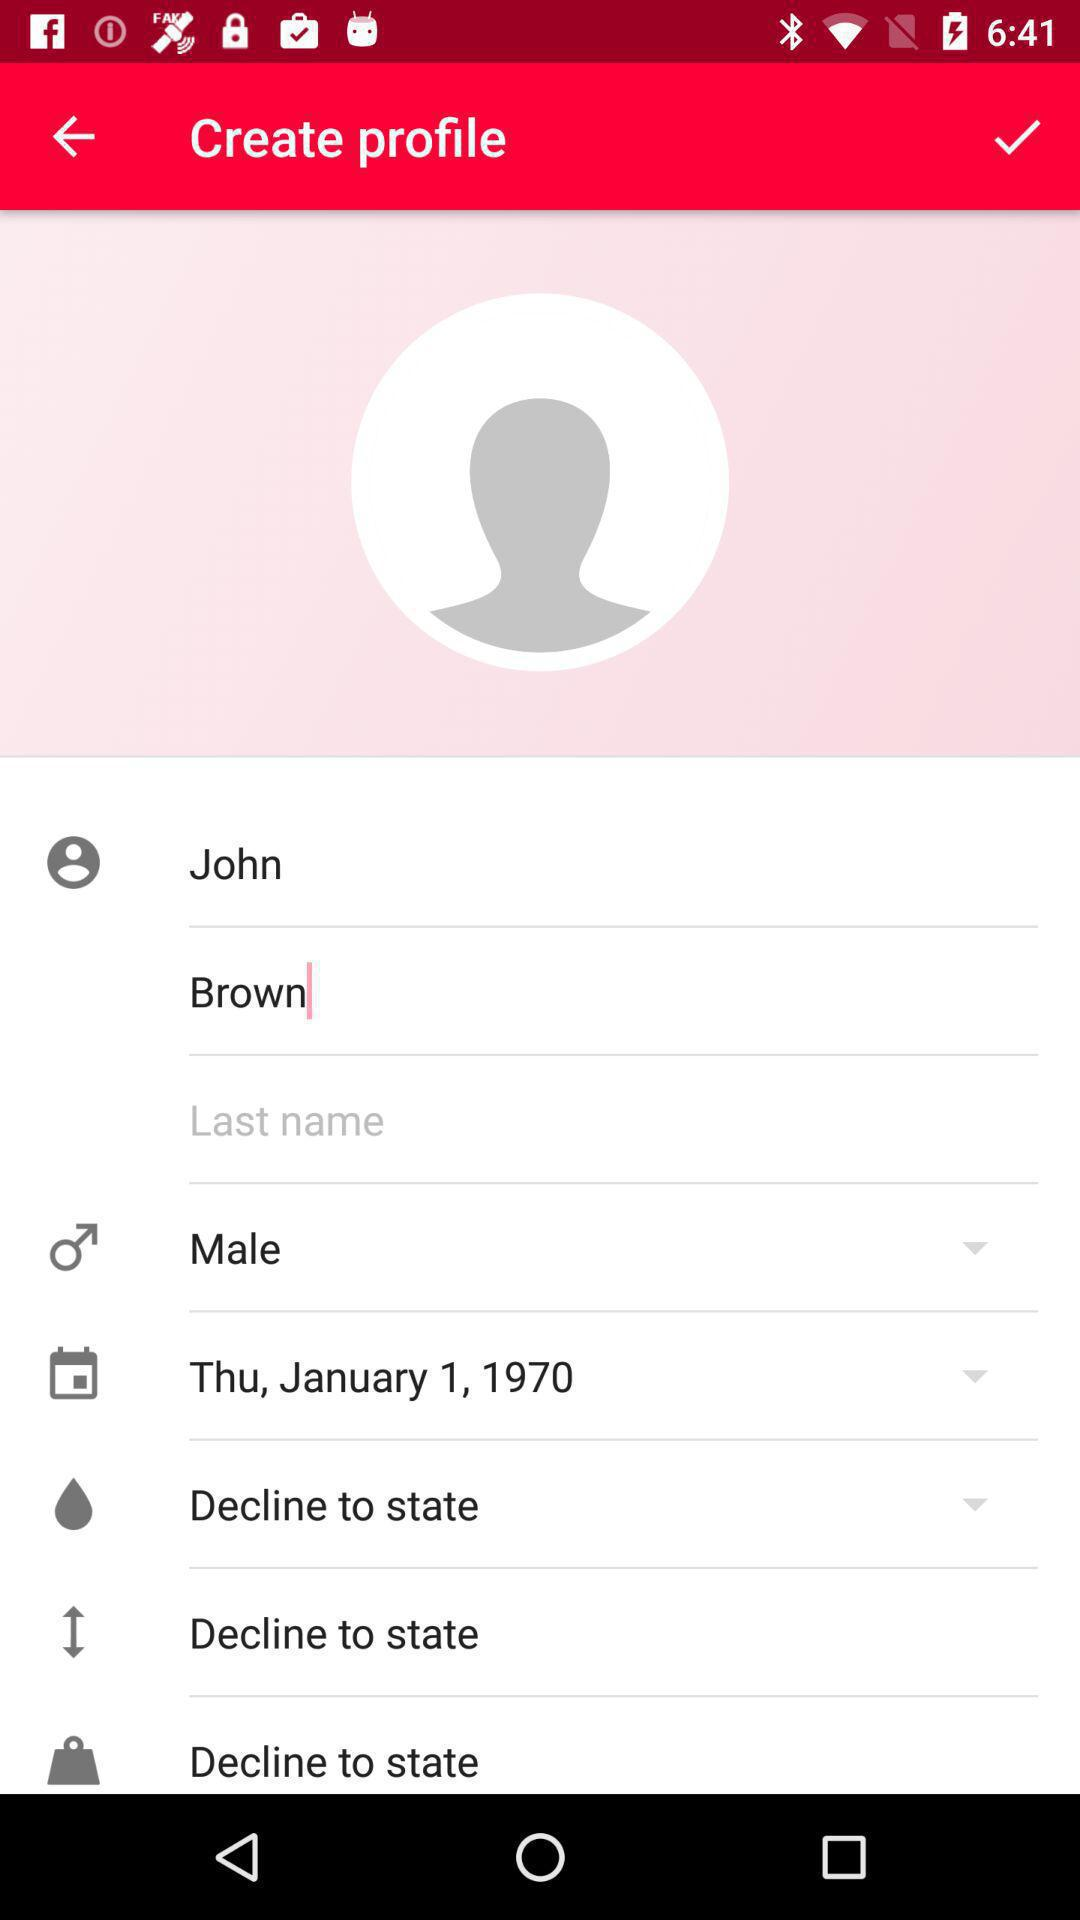What is the gender of the user? The gender of the user is male. 